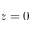Convert formula to latex. <formula><loc_0><loc_0><loc_500><loc_500>z = 0</formula> 